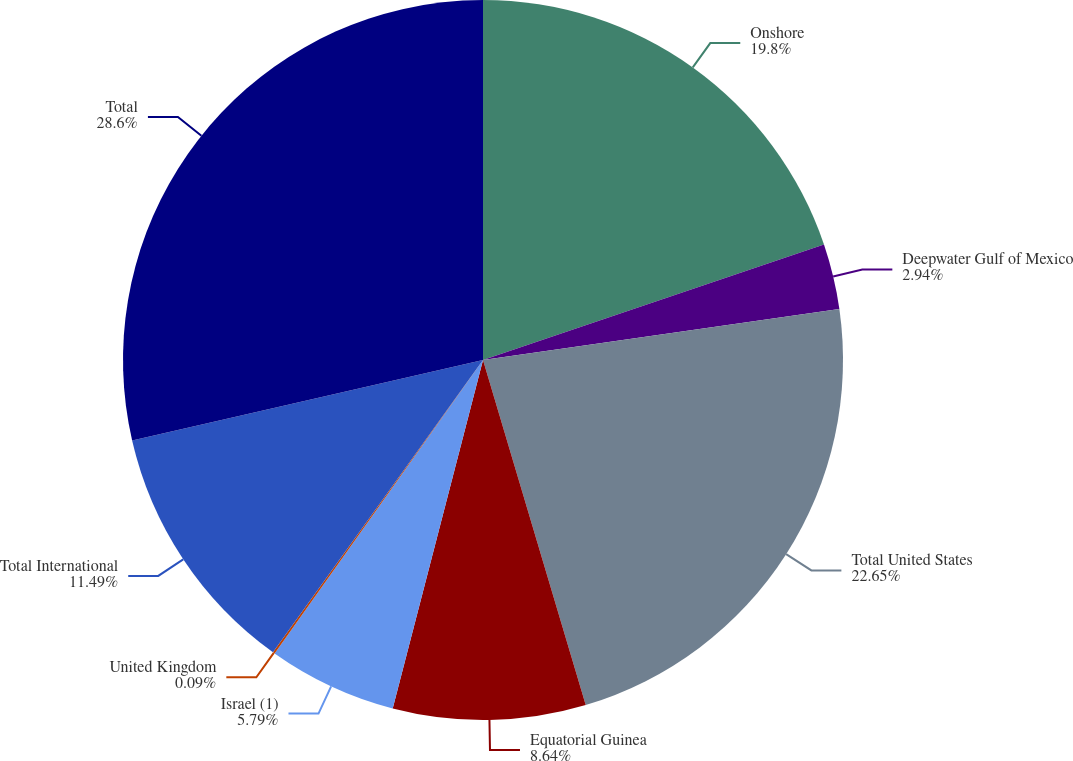Convert chart to OTSL. <chart><loc_0><loc_0><loc_500><loc_500><pie_chart><fcel>Onshore<fcel>Deepwater Gulf of Mexico<fcel>Total United States<fcel>Equatorial Guinea<fcel>Israel (1)<fcel>United Kingdom<fcel>Total International<fcel>Total<nl><fcel>19.8%<fcel>2.94%<fcel>22.65%<fcel>8.64%<fcel>5.79%<fcel>0.09%<fcel>11.49%<fcel>28.59%<nl></chart> 